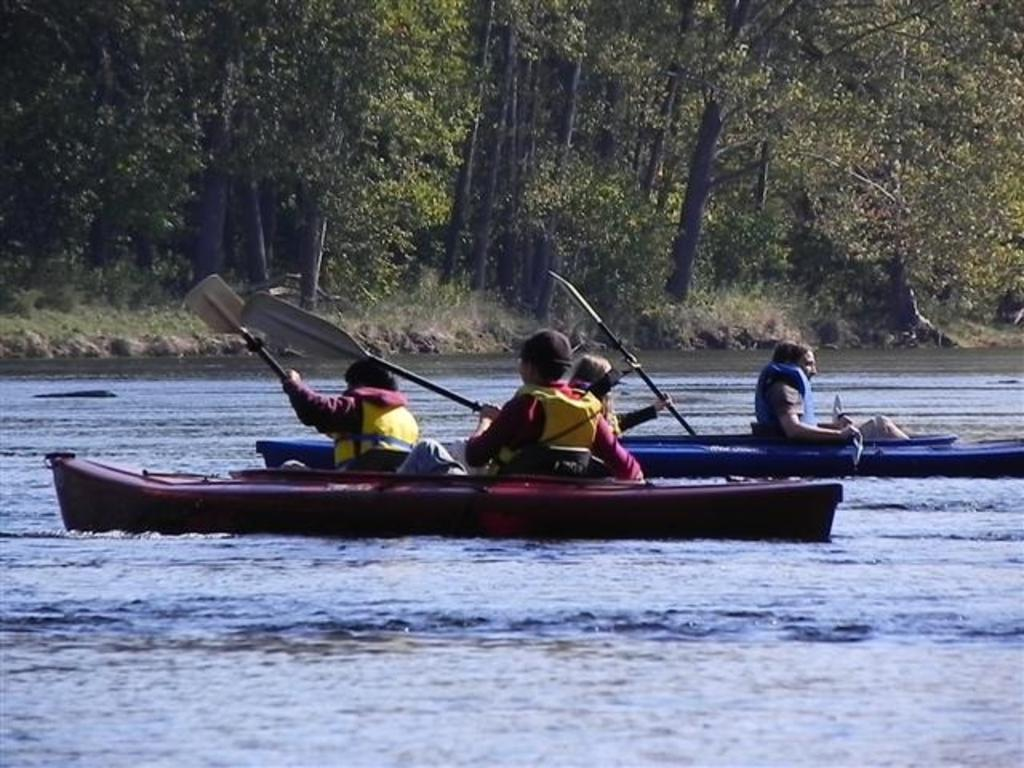What are the persons in the image doing? The persons in the image are sitting in a boat. What are the persons holding in the image? The persons are holding bows. Where is the boat located in the image? The boat is sailing on water. What can be seen in the background of the image? There are trees in the background of the image. What type of teeth can be seen in the image? There are no teeth visible in the image; it features persons sitting in a boat holding bows while sailing on water. 